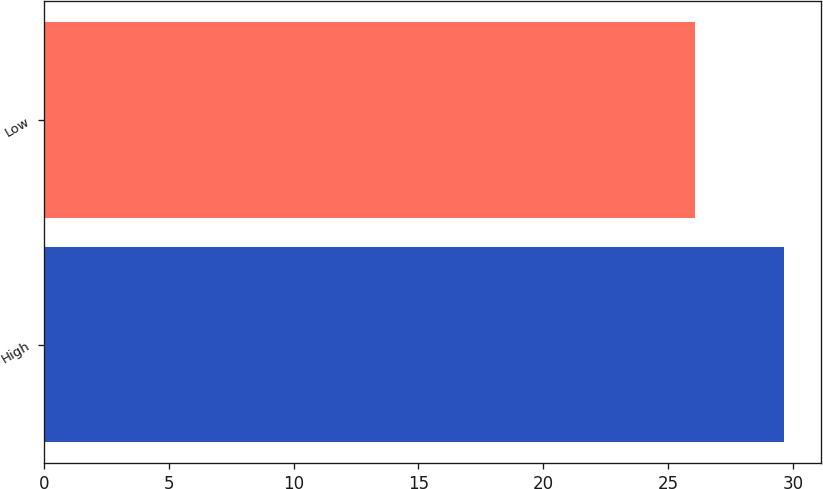<chart> <loc_0><loc_0><loc_500><loc_500><bar_chart><fcel>High<fcel>Low<nl><fcel>29.63<fcel>26.1<nl></chart> 